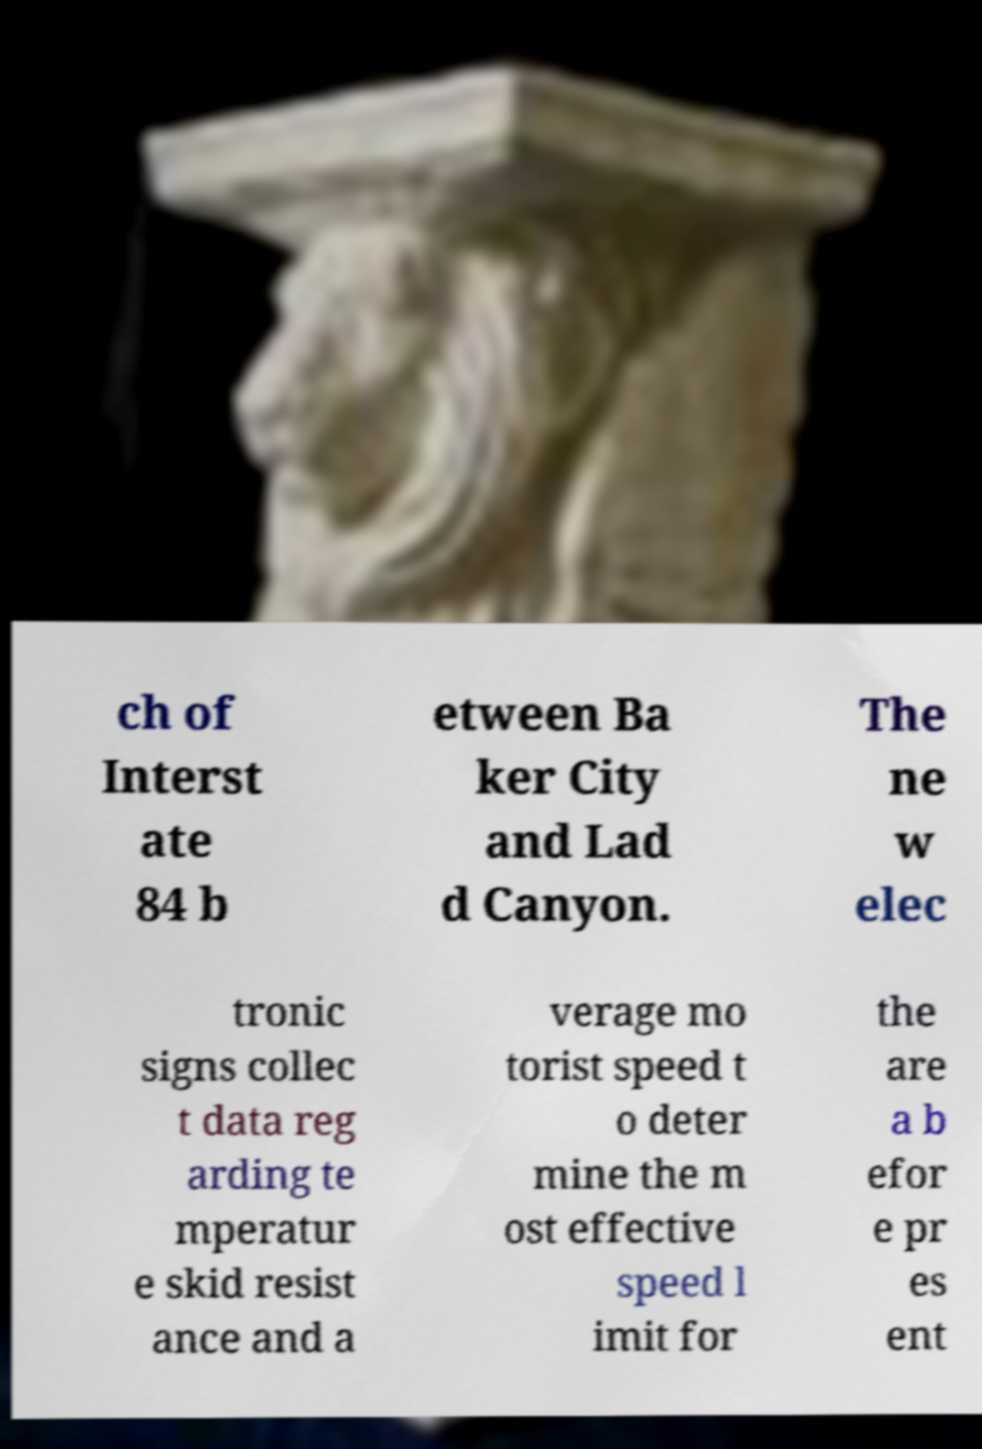There's text embedded in this image that I need extracted. Can you transcribe it verbatim? ch of Interst ate 84 b etween Ba ker City and Lad d Canyon. The ne w elec tronic signs collec t data reg arding te mperatur e skid resist ance and a verage mo torist speed t o deter mine the m ost effective speed l imit for the are a b efor e pr es ent 